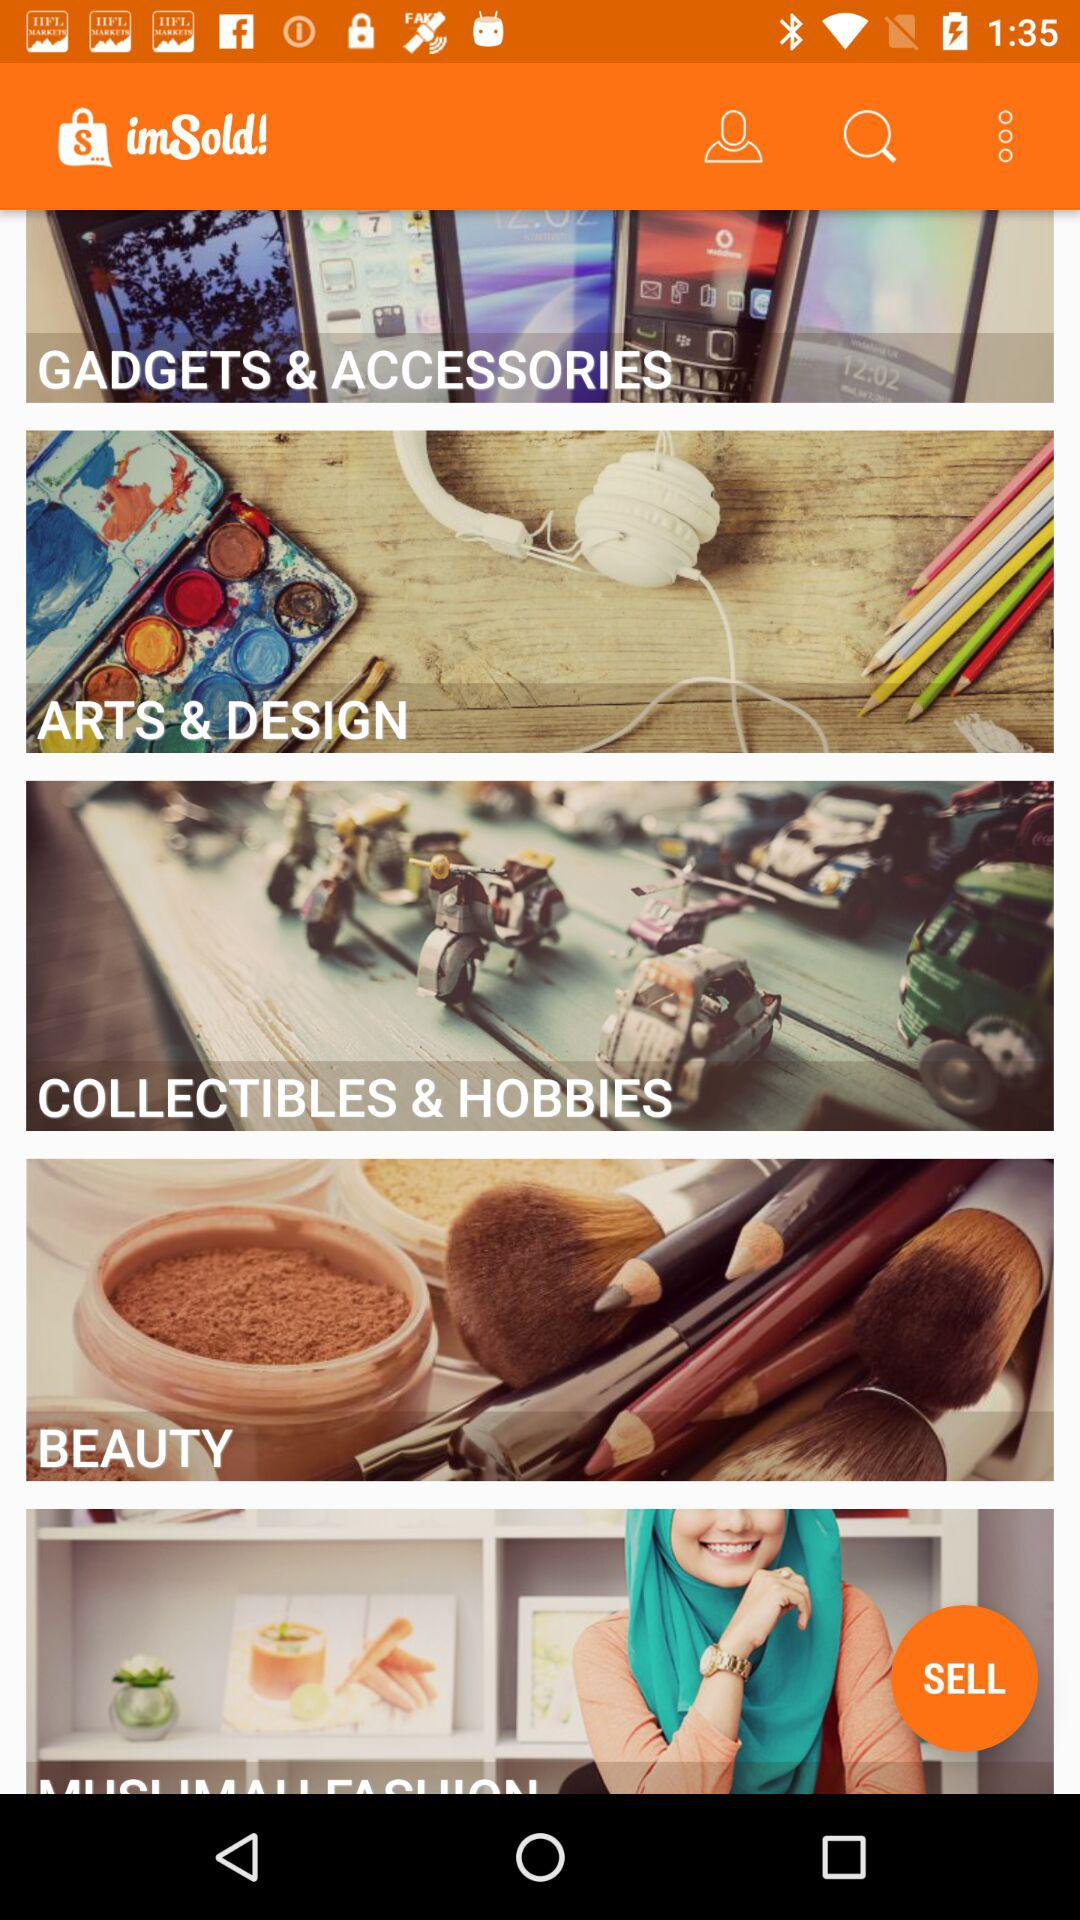How many "BEAUTY" items are there?
When the provided information is insufficient, respond with <no answer>. <no answer> 